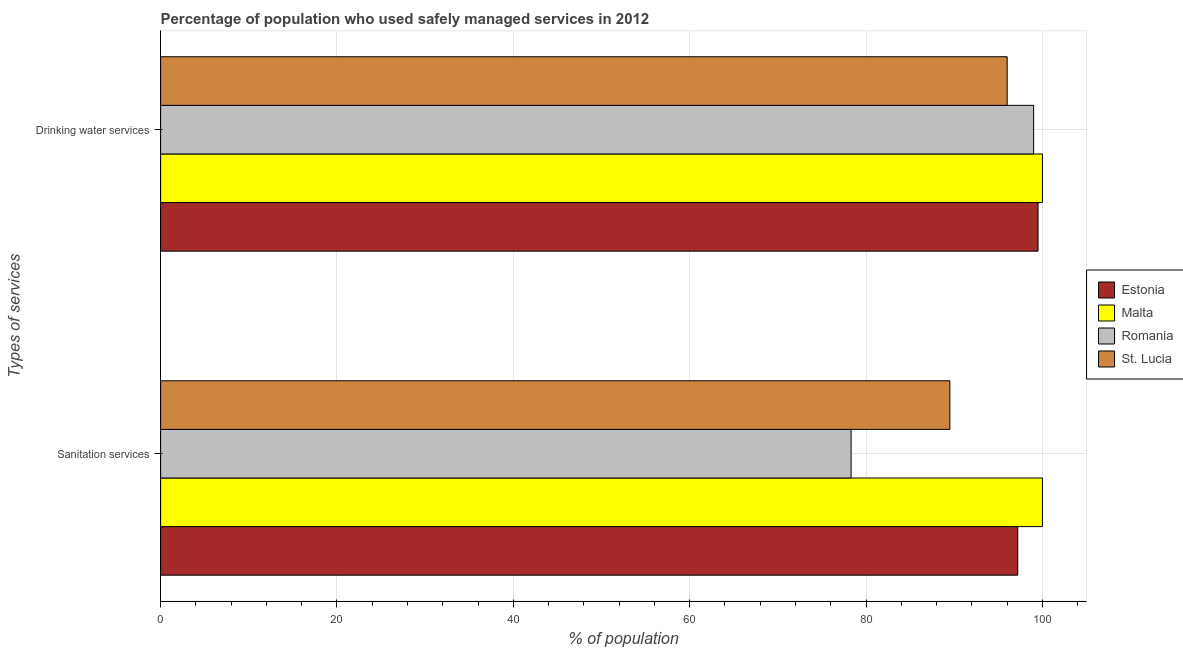How many groups of bars are there?
Ensure brevity in your answer.  2. Are the number of bars per tick equal to the number of legend labels?
Your answer should be very brief. Yes. Are the number of bars on each tick of the Y-axis equal?
Keep it short and to the point. Yes. How many bars are there on the 2nd tick from the top?
Give a very brief answer. 4. What is the label of the 1st group of bars from the top?
Your answer should be compact. Drinking water services. What is the percentage of population who used sanitation services in Malta?
Your answer should be compact. 100. Across all countries, what is the maximum percentage of population who used sanitation services?
Your answer should be compact. 100. Across all countries, what is the minimum percentage of population who used sanitation services?
Offer a terse response. 78.3. In which country was the percentage of population who used sanitation services maximum?
Your answer should be very brief. Malta. In which country was the percentage of population who used sanitation services minimum?
Ensure brevity in your answer.  Romania. What is the total percentage of population who used sanitation services in the graph?
Your answer should be very brief. 365. What is the difference between the percentage of population who used drinking water services in Romania and that in Estonia?
Your response must be concise. -0.5. What is the difference between the percentage of population who used drinking water services in Romania and the percentage of population who used sanitation services in Estonia?
Offer a very short reply. 1.8. What is the average percentage of population who used sanitation services per country?
Offer a terse response. 91.25. What is the difference between the percentage of population who used sanitation services and percentage of population who used drinking water services in Estonia?
Offer a terse response. -2.3. What is the ratio of the percentage of population who used sanitation services in Estonia to that in Romania?
Give a very brief answer. 1.24. In how many countries, is the percentage of population who used drinking water services greater than the average percentage of population who used drinking water services taken over all countries?
Your response must be concise. 3. What does the 2nd bar from the top in Drinking water services represents?
Make the answer very short. Romania. What does the 2nd bar from the bottom in Drinking water services represents?
Make the answer very short. Malta. How many bars are there?
Your answer should be very brief. 8. How many countries are there in the graph?
Keep it short and to the point. 4. Does the graph contain any zero values?
Your response must be concise. No. Where does the legend appear in the graph?
Provide a succinct answer. Center right. How many legend labels are there?
Provide a short and direct response. 4. How are the legend labels stacked?
Keep it short and to the point. Vertical. What is the title of the graph?
Keep it short and to the point. Percentage of population who used safely managed services in 2012. What is the label or title of the X-axis?
Your answer should be compact. % of population. What is the label or title of the Y-axis?
Offer a very short reply. Types of services. What is the % of population of Estonia in Sanitation services?
Offer a very short reply. 97.2. What is the % of population of Malta in Sanitation services?
Keep it short and to the point. 100. What is the % of population in Romania in Sanitation services?
Your answer should be compact. 78.3. What is the % of population in St. Lucia in Sanitation services?
Provide a short and direct response. 89.5. What is the % of population of Estonia in Drinking water services?
Keep it short and to the point. 99.5. What is the % of population of Malta in Drinking water services?
Provide a short and direct response. 100. What is the % of population of St. Lucia in Drinking water services?
Offer a terse response. 96. Across all Types of services, what is the maximum % of population in Estonia?
Your response must be concise. 99.5. Across all Types of services, what is the maximum % of population of Malta?
Make the answer very short. 100. Across all Types of services, what is the maximum % of population in Romania?
Your answer should be very brief. 99. Across all Types of services, what is the maximum % of population of St. Lucia?
Your answer should be compact. 96. Across all Types of services, what is the minimum % of population in Estonia?
Your answer should be very brief. 97.2. Across all Types of services, what is the minimum % of population of Romania?
Keep it short and to the point. 78.3. Across all Types of services, what is the minimum % of population in St. Lucia?
Your answer should be very brief. 89.5. What is the total % of population of Estonia in the graph?
Offer a very short reply. 196.7. What is the total % of population in Malta in the graph?
Your answer should be very brief. 200. What is the total % of population of Romania in the graph?
Make the answer very short. 177.3. What is the total % of population of St. Lucia in the graph?
Offer a very short reply. 185.5. What is the difference between the % of population in Romania in Sanitation services and that in Drinking water services?
Offer a terse response. -20.7. What is the difference between the % of population in Estonia in Sanitation services and the % of population in St. Lucia in Drinking water services?
Offer a very short reply. 1.2. What is the difference between the % of population of Malta in Sanitation services and the % of population of Romania in Drinking water services?
Give a very brief answer. 1. What is the difference between the % of population in Malta in Sanitation services and the % of population in St. Lucia in Drinking water services?
Make the answer very short. 4. What is the difference between the % of population of Romania in Sanitation services and the % of population of St. Lucia in Drinking water services?
Give a very brief answer. -17.7. What is the average % of population in Estonia per Types of services?
Give a very brief answer. 98.35. What is the average % of population of Malta per Types of services?
Your answer should be compact. 100. What is the average % of population in Romania per Types of services?
Your response must be concise. 88.65. What is the average % of population in St. Lucia per Types of services?
Offer a terse response. 92.75. What is the difference between the % of population in Estonia and % of population in St. Lucia in Sanitation services?
Offer a very short reply. 7.7. What is the difference between the % of population in Malta and % of population in Romania in Sanitation services?
Provide a short and direct response. 21.7. What is the difference between the % of population in Malta and % of population in St. Lucia in Sanitation services?
Keep it short and to the point. 10.5. What is the difference between the % of population in Estonia and % of population in Romania in Drinking water services?
Make the answer very short. 0.5. What is the difference between the % of population of Estonia and % of population of St. Lucia in Drinking water services?
Keep it short and to the point. 3.5. What is the ratio of the % of population in Estonia in Sanitation services to that in Drinking water services?
Offer a terse response. 0.98. What is the ratio of the % of population in Romania in Sanitation services to that in Drinking water services?
Your answer should be very brief. 0.79. What is the ratio of the % of population in St. Lucia in Sanitation services to that in Drinking water services?
Keep it short and to the point. 0.93. What is the difference between the highest and the second highest % of population of Estonia?
Your response must be concise. 2.3. What is the difference between the highest and the second highest % of population of Romania?
Your response must be concise. 20.7. What is the difference between the highest and the lowest % of population of Malta?
Provide a succinct answer. 0. What is the difference between the highest and the lowest % of population in Romania?
Your response must be concise. 20.7. 